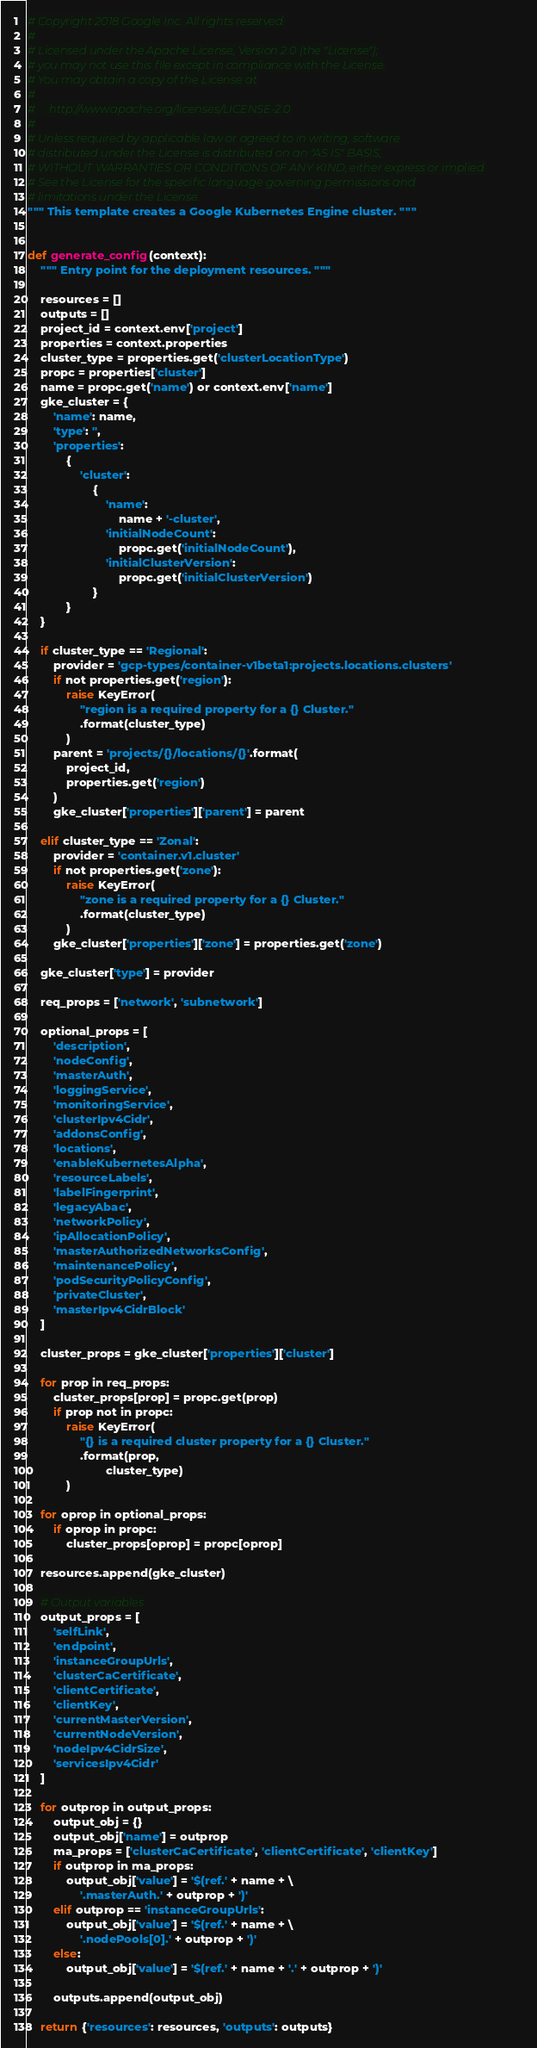Convert code to text. <code><loc_0><loc_0><loc_500><loc_500><_Python_># Copyright 2018 Google Inc. All rights reserved.
#
# Licensed under the Apache License, Version 2.0 (the "License");
# you may not use this file except in compliance with the License.
# You may obtain a copy of the License at
#
#     http://www.apache.org/licenses/LICENSE-2.0
#
# Unless required by applicable law or agreed to in writing, software
# distributed under the License is distributed on an "AS IS" BASIS,
# WITHOUT WARRANTIES OR CONDITIONS OF ANY KIND, either express or implied.
# See the License for the specific language governing permissions and
# limitations under the License.
""" This template creates a Google Kubernetes Engine cluster. """


def generate_config(context):
    """ Entry point for the deployment resources. """

    resources = []
    outputs = []
    project_id = context.env['project']
    properties = context.properties
    cluster_type = properties.get('clusterLocationType')
    propc = properties['cluster']
    name = propc.get('name') or context.env['name']
    gke_cluster = {
        'name': name,
        'type': '',
        'properties':
            {
                'cluster':
                    {
                        'name':
                            name + '-cluster',
                        'initialNodeCount':
                            propc.get('initialNodeCount'),
                        'initialClusterVersion':
                            propc.get('initialClusterVersion')
                    }
            }
    }

    if cluster_type == 'Regional':
        provider = 'gcp-types/container-v1beta1:projects.locations.clusters'
        if not properties.get('region'):
            raise KeyError(
                "region is a required property for a {} Cluster."
                .format(cluster_type)
            )
        parent = 'projects/{}/locations/{}'.format(
            project_id,
            properties.get('region')
        )
        gke_cluster['properties']['parent'] = parent

    elif cluster_type == 'Zonal':
        provider = 'container.v1.cluster'
        if not properties.get('zone'):
            raise KeyError(
                "zone is a required property for a {} Cluster."
                .format(cluster_type)
            )
        gke_cluster['properties']['zone'] = properties.get('zone')

    gke_cluster['type'] = provider

    req_props = ['network', 'subnetwork']

    optional_props = [
        'description',
        'nodeConfig',
        'masterAuth',
        'loggingService',
        'monitoringService',
        'clusterIpv4Cidr',
        'addonsConfig',
        'locations',
        'enableKubernetesAlpha',
        'resourceLabels',
        'labelFingerprint',
        'legacyAbac',
        'networkPolicy',
        'ipAllocationPolicy',
        'masterAuthorizedNetworksConfig',
        'maintenancePolicy',
        'podSecurityPolicyConfig',
        'privateCluster',
        'masterIpv4CidrBlock'
    ]

    cluster_props = gke_cluster['properties']['cluster']

    for prop in req_props:
        cluster_props[prop] = propc.get(prop)
        if prop not in propc:
            raise KeyError(
                "{} is a required cluster property for a {} Cluster."
                .format(prop,
                        cluster_type)
            )

    for oprop in optional_props:
        if oprop in propc:
            cluster_props[oprop] = propc[oprop]

    resources.append(gke_cluster)

    # Output variables
    output_props = [
        'selfLink',
        'endpoint',
        'instanceGroupUrls',
        'clusterCaCertificate',
        'clientCertificate',
        'clientKey',
        'currentMasterVersion',
        'currentNodeVersion',
        'nodeIpv4CidrSize',
        'servicesIpv4Cidr'
    ]

    for outprop in output_props:
        output_obj = {}
        output_obj['name'] = outprop
        ma_props = ['clusterCaCertificate', 'clientCertificate', 'clientKey']
        if outprop in ma_props:
            output_obj['value'] = '$(ref.' + name + \
                '.masterAuth.' + outprop + ')'
        elif outprop == 'instanceGroupUrls':
            output_obj['value'] = '$(ref.' + name + \
                '.nodePools[0].' + outprop + ')'
        else:
            output_obj['value'] = '$(ref.' + name + '.' + outprop + ')'

        outputs.append(output_obj)

    return {'resources': resources, 'outputs': outputs}
</code> 